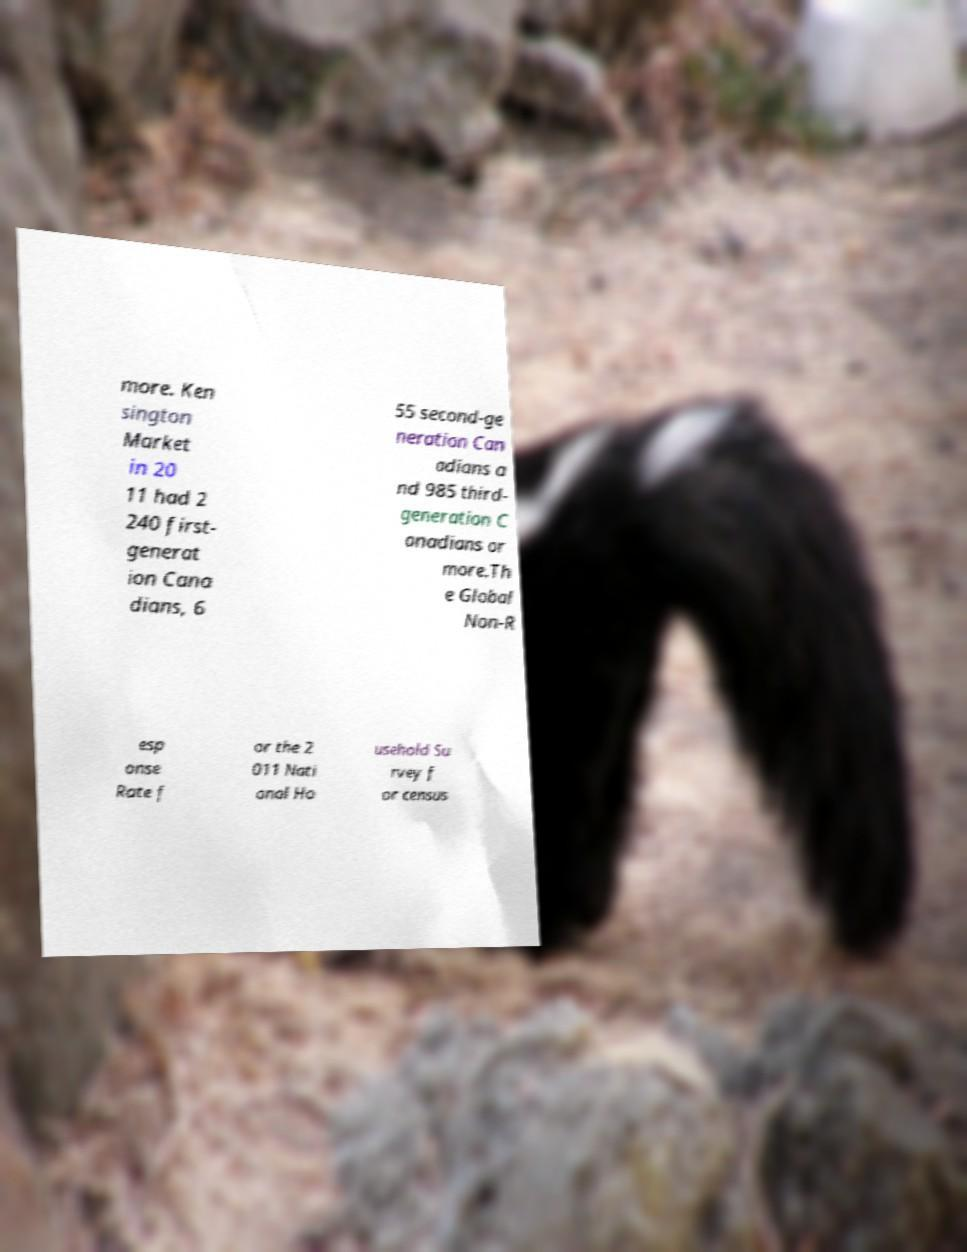What messages or text are displayed in this image? I need them in a readable, typed format. more. Ken sington Market in 20 11 had 2 240 first- generat ion Cana dians, 6 55 second-ge neration Can adians a nd 985 third- generation C anadians or more.Th e Global Non-R esp onse Rate f or the 2 011 Nati onal Ho usehold Su rvey f or census 